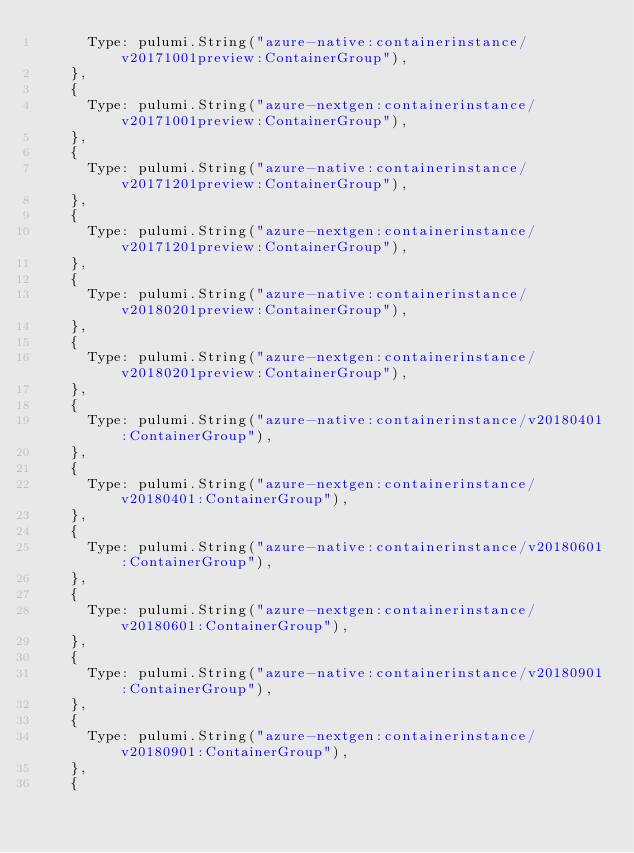Convert code to text. <code><loc_0><loc_0><loc_500><loc_500><_Go_>			Type: pulumi.String("azure-native:containerinstance/v20171001preview:ContainerGroup"),
		},
		{
			Type: pulumi.String("azure-nextgen:containerinstance/v20171001preview:ContainerGroup"),
		},
		{
			Type: pulumi.String("azure-native:containerinstance/v20171201preview:ContainerGroup"),
		},
		{
			Type: pulumi.String("azure-nextgen:containerinstance/v20171201preview:ContainerGroup"),
		},
		{
			Type: pulumi.String("azure-native:containerinstance/v20180201preview:ContainerGroup"),
		},
		{
			Type: pulumi.String("azure-nextgen:containerinstance/v20180201preview:ContainerGroup"),
		},
		{
			Type: pulumi.String("azure-native:containerinstance/v20180401:ContainerGroup"),
		},
		{
			Type: pulumi.String("azure-nextgen:containerinstance/v20180401:ContainerGroup"),
		},
		{
			Type: pulumi.String("azure-native:containerinstance/v20180601:ContainerGroup"),
		},
		{
			Type: pulumi.String("azure-nextgen:containerinstance/v20180601:ContainerGroup"),
		},
		{
			Type: pulumi.String("azure-native:containerinstance/v20180901:ContainerGroup"),
		},
		{
			Type: pulumi.String("azure-nextgen:containerinstance/v20180901:ContainerGroup"),
		},
		{</code> 